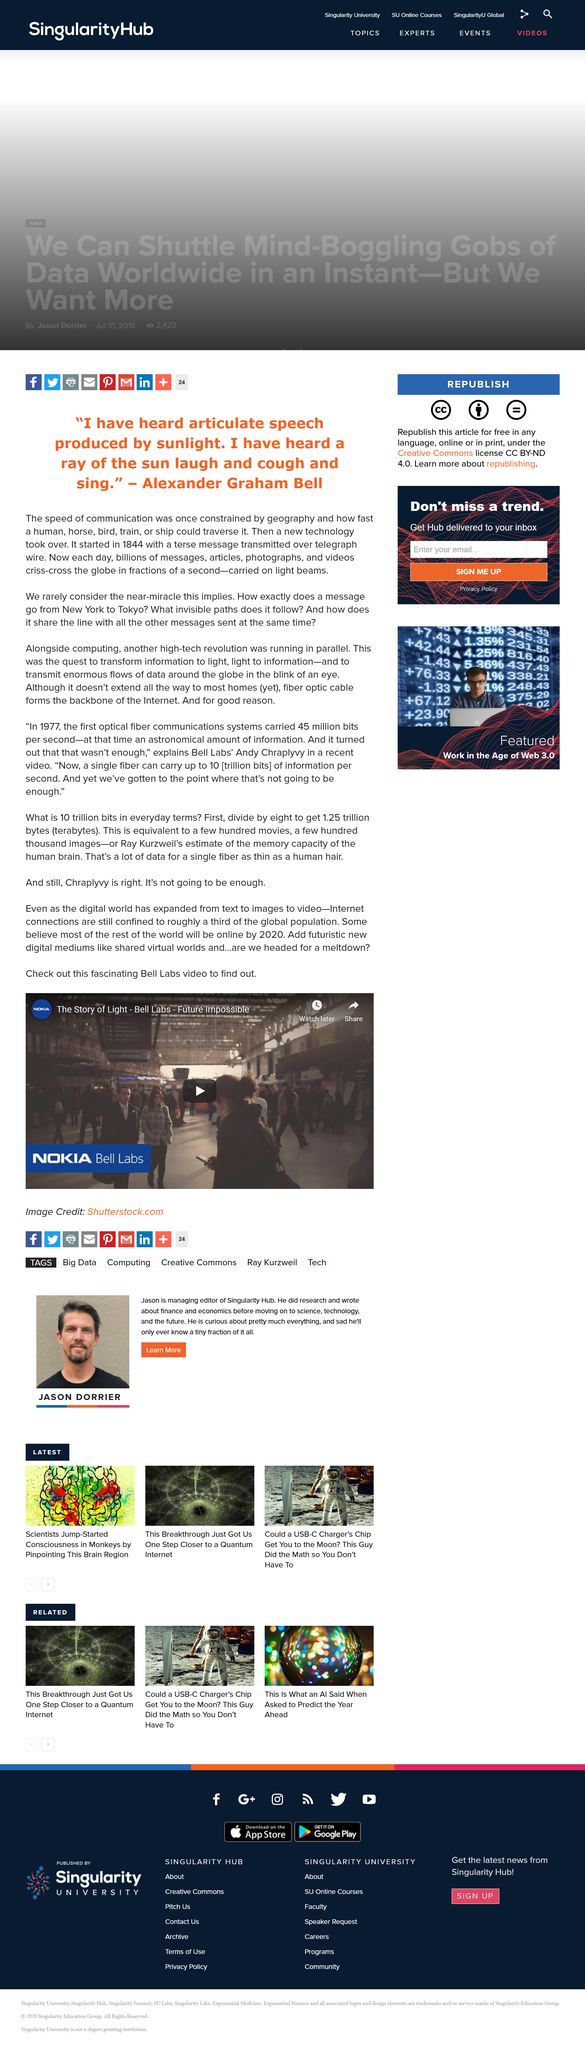Draw attention to some important aspects in this diagram. The title of the Bell Labs video is "The Story of Light - Bell Labs - Future Impossible. There are approximately 1.25 trillion bits in 1.25 terabytes. The fibre optic cable is the backbone of the internet. The speed at which data travels across the internet is at the speed of light. Alexander Graham Bell is the person who stated, "I have heard a ray of the sun laugh and cough and sing. 